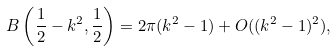<formula> <loc_0><loc_0><loc_500><loc_500>B \left ( \frac { 1 } { 2 } - k ^ { 2 } , \frac { 1 } { 2 } \right ) = 2 \pi ( k ^ { 2 } - 1 ) + O ( ( k ^ { 2 } - 1 ) ^ { 2 } ) ,</formula> 